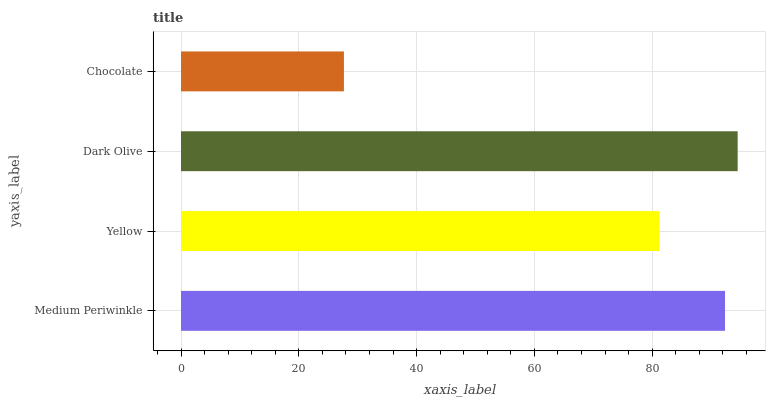Is Chocolate the minimum?
Answer yes or no. Yes. Is Dark Olive the maximum?
Answer yes or no. Yes. Is Yellow the minimum?
Answer yes or no. No. Is Yellow the maximum?
Answer yes or no. No. Is Medium Periwinkle greater than Yellow?
Answer yes or no. Yes. Is Yellow less than Medium Periwinkle?
Answer yes or no. Yes. Is Yellow greater than Medium Periwinkle?
Answer yes or no. No. Is Medium Periwinkle less than Yellow?
Answer yes or no. No. Is Medium Periwinkle the high median?
Answer yes or no. Yes. Is Yellow the low median?
Answer yes or no. Yes. Is Chocolate the high median?
Answer yes or no. No. Is Chocolate the low median?
Answer yes or no. No. 